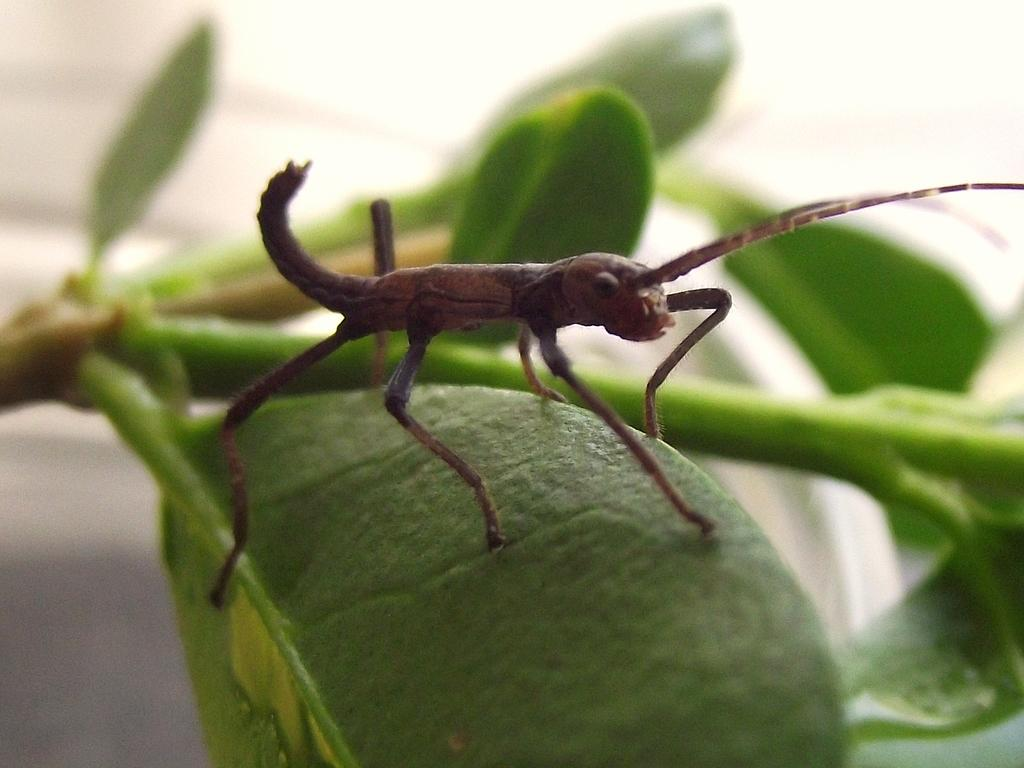What is the main subject of the image? There is an insect on a leaf in the image. What can be seen in the background of the image? Plant branches are visible in the background of the image. How would you describe the appearance of the background? The background of the image appears blurry. What type of roof can be seen in the image? There is no roof present in the image; it features an insect on a leaf with a blurry background. 